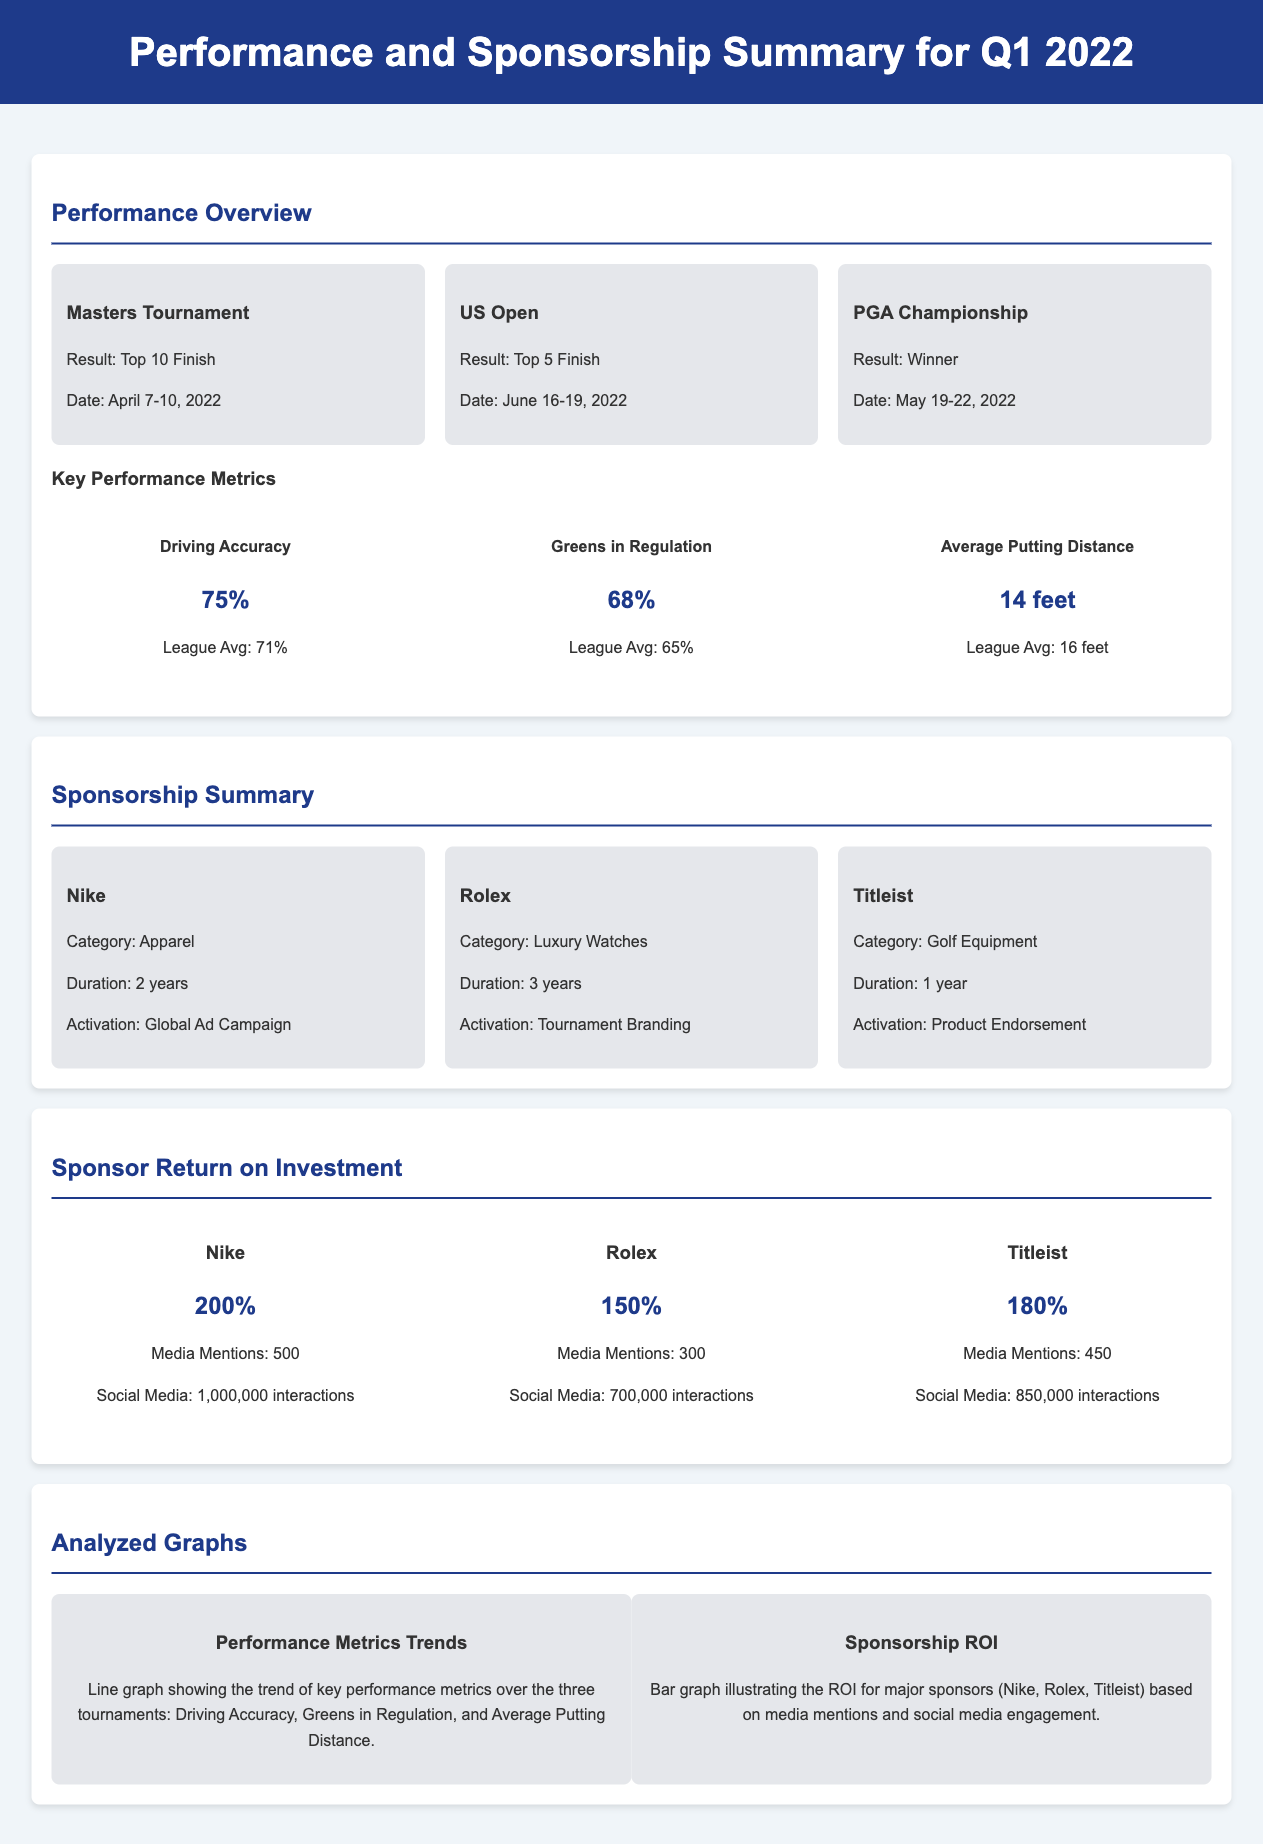What was the result of the PGA Championship? The PGA Championship result is stated as "Winner" in the document.
Answer: Winner What is the Driving Accuracy percentage? The Driving Accuracy percentage is provided as a key performance metric in the document.
Answer: 75% What is the duration of the sponsorship with Rolex? The document specifies the duration of the Rolex sponsorship.
Answer: 3 years How many media mentions did Nike receive? The number of media mentions for Nike is listed in the Sponsor Return on Investment section of the document.
Answer: 500 Which tournament was held on June 16-19, 2022? The date specified corresponds to a particular tournament mentioned in the document.
Answer: US Open What is the ROI percentage for Titleist? The ROI percentage for Titleist is provided in the Sponsor Return on Investment section.
Answer: 180% How many interactions did Rolex receive on social media? The document notes the number of social media interactions for Rolex.
Answer: 700,000 Which performance metric had a league average of 16 feet? The league average mentioned corresponds to a specific performance metric in the document.
Answer: Average Putting Distance What type of graph illustrates the sponsorship ROI? The document describes the type of graph used to visualize sponsorship ROI.
Answer: Bar graph 